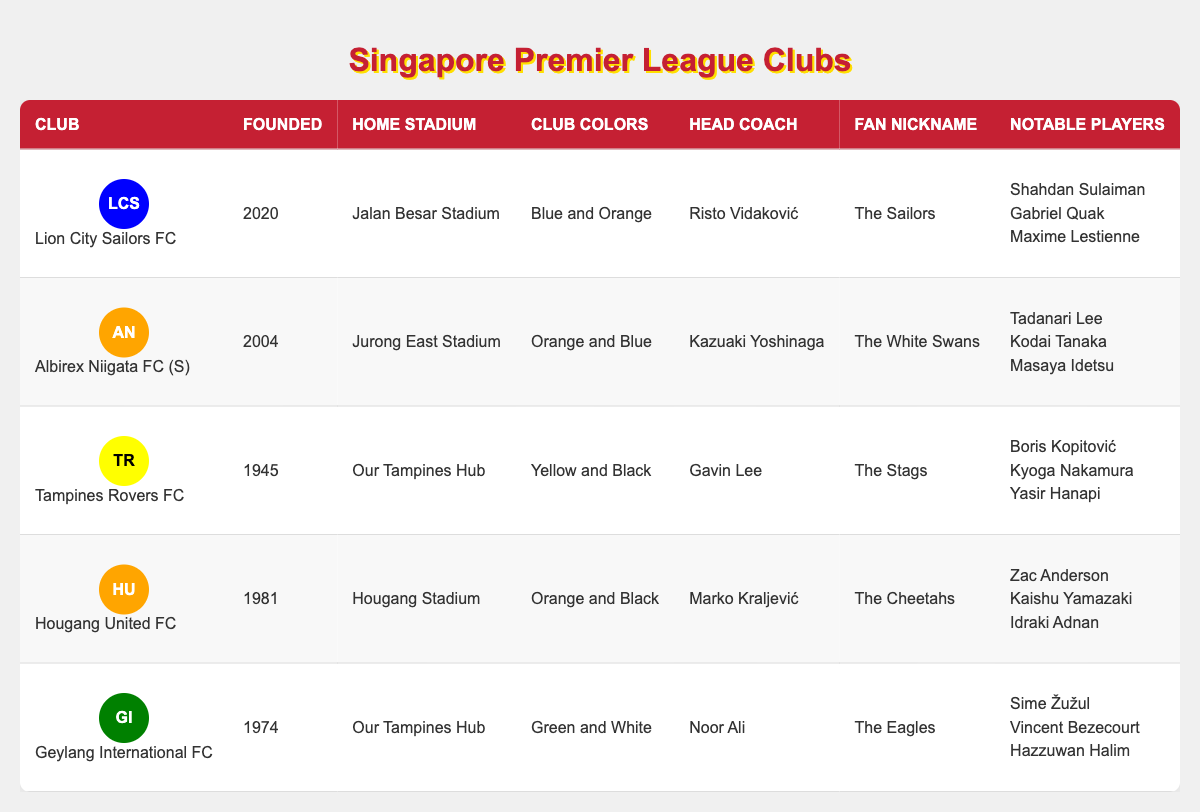What year was Lion City Sailors FC founded? Lion City Sailors FC is listed in the table, and the founded year is provided in the relevant column. The table shows that the club was founded in 2020.
Answer: 2020 How many major trophies have Tampines Rovers FC won? Tampines Rovers FC is listed in the table, and the number of major trophies is specified in the corresponding column. The table indicates that they have won 5 major trophies.
Answer: 5 Which club has the fan nickname "The Eagles"? By looking at the table, I can locate the club that has "The Eagles" as its fan nickname. The table shows that Geylang International FC has this nickname.
Answer: Geylang International FC Is Hougang United FC the oldest club in this table? In the table, I can check the founding years of each club. Comparing the years, Tampines Rovers FC founded in 1945 is older than Hougang United FC, which was founded in 1981. Thus, Hougang United FC is not the oldest club.
Answer: No What is the home stadium of Albirex Niigata FC (S)? The table includes a home stadium column for each club. By checking this column for Albirex Niigata FC (S), I see that its home stadium is Jurong East Stadium.
Answer: Jurong East Stadium How many clubs have won more than 2 major trophies? To determine this, I will count the number of clubs with a trophy count greater than 2. In the table, Tamplines Rovers FC (5) and Albirex Niigata FC (S) (4) fit this criterion, totaling 2 clubs.
Answer: 2 Which club has the most notable players listed? I’ll compare the number of notable players listed for each club in the table. Lion City Sailors FC and Tampines Rovers FC each have 3 notable players listed, while other clubs have fewer. Therefore, that indicates a tie.
Answer: Lion City Sailors FC and Tampines Rovers FC If I sum the founding years of all clubs, what is the result? Summing the founding years requires adding 2020 (Lion City Sailors FC) + 2004 (Albirex Niigata FC) + 1945 (Tampines Rovers FC) + 1981 (Hougang United FC) + 1974 (Geylang International FC), which equals 10,624.
Answer: 10,624 